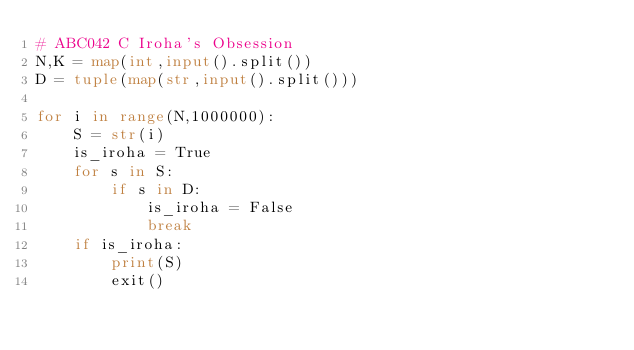Convert code to text. <code><loc_0><loc_0><loc_500><loc_500><_Python_># ABC042 C Iroha's Obsession
N,K = map(int,input().split())
D = tuple(map(str,input().split()))

for i in range(N,1000000):
    S = str(i)
    is_iroha = True
    for s in S:
        if s in D:
            is_iroha = False
            break
    if is_iroha:
        print(S)
        exit()
</code> 